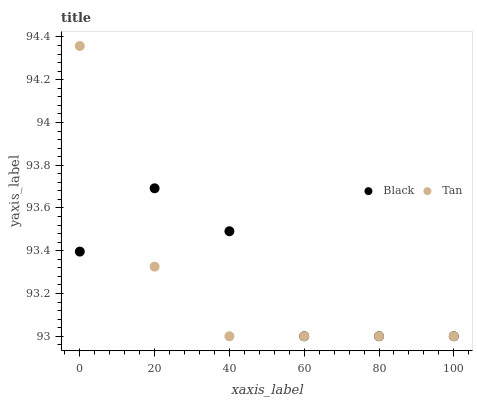Does Tan have the minimum area under the curve?
Answer yes or no. Yes. Does Black have the maximum area under the curve?
Answer yes or no. Yes. Does Black have the minimum area under the curve?
Answer yes or no. No. Is Tan the smoothest?
Answer yes or no. Yes. Is Black the roughest?
Answer yes or no. Yes. Is Black the smoothest?
Answer yes or no. No. Does Tan have the lowest value?
Answer yes or no. Yes. Does Tan have the highest value?
Answer yes or no. Yes. Does Black have the highest value?
Answer yes or no. No. Does Tan intersect Black?
Answer yes or no. Yes. Is Tan less than Black?
Answer yes or no. No. Is Tan greater than Black?
Answer yes or no. No. 